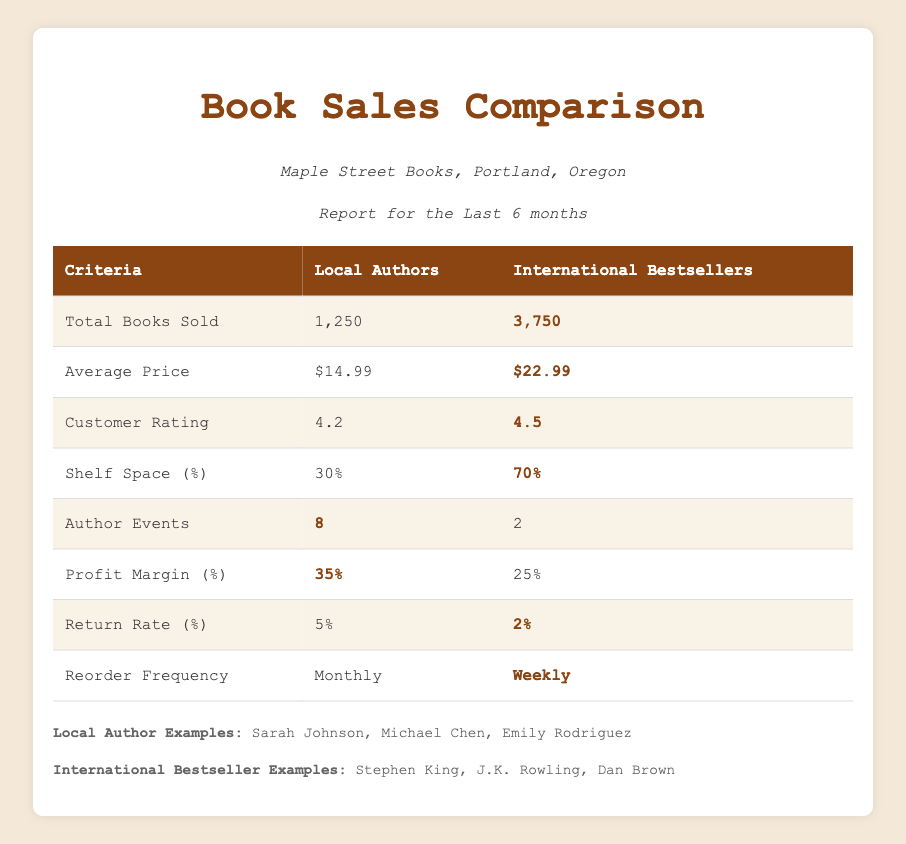What is the total number of books sold for local authors? The total number of books sold for local authors is directly listed in the table under the "Local Authors" column next to "Total Books Sold." It shows 1250.
Answer: 1250 How much higher is the average price of international bestsellers compared to local authors? To find the difference, subtract the average price of local authors ($14.99) from the average price of international bestsellers ($22.99). So, $22.99 - $14.99 = $8.00.
Answer: $8.00 Is the return rate for international bestsellers lower than for local authors? Looking at the return rates in the table, international bestsellers have a return rate of 2%, while local authors have a return rate of 5%. Since 2% is less than 5%, the statement is true.
Answer: Yes What percentage of shelf space is occupied by local authors? The table shows that local authors occupy 30% of shelf space, which is clearly indicated under "Shelf Space (%)" in the "Local Authors" column.
Answer: 30% If we consider the profit margin and total books sold for both groups, what is the profit from local authors? The profit from local authors can be calculated by multiplying the total books sold (1250) by the profit margin (35%). First, convert the profit margin into a decimal form: 35% = 0.35. Then calculate: 1250 * 0.35 = 437.50. So, local authors generate a profit of $437.50.
Answer: $437.50 How often do local authors' books need to be reordered compared to international bestsellers? According to the table, local authors’ books need to be reordered monthly while international bestsellers' books are reordered weekly. So, local authors have a less frequent reorder cycle (monthly compared to weekly).
Answer: Less frequent (monthly) Which category has more author events? By reviewing the "Author Events" row in the table, local authors host 8 events, while international bestsellers host only 2 events, making it clear that local authors have more author events.
Answer: Local authors If we combine the total books sold for both groups, how many books were sold overall? To find the total books sold for both local authors and international bestsellers, we add the two figures together: 1250 (local authors) + 3750 (international bestsellers) = 5000. Overall, a total of 5000 books were sold.
Answer: 5000 